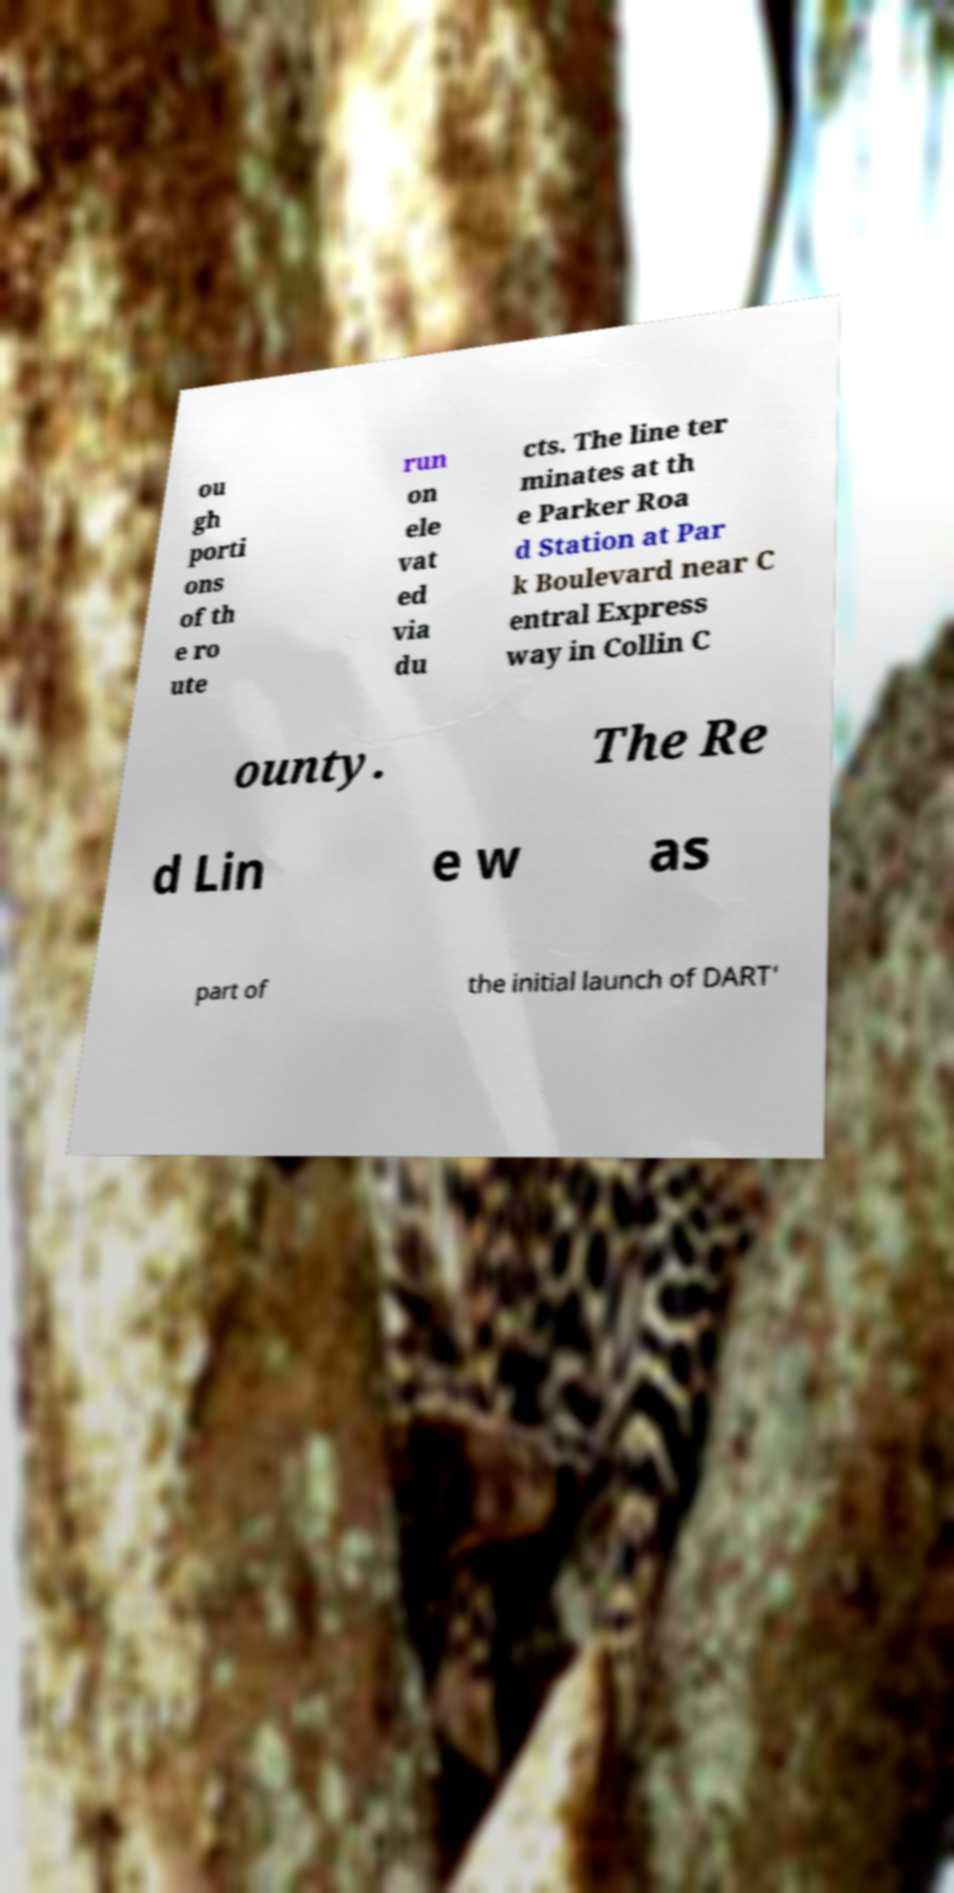What messages or text are displayed in this image? I need them in a readable, typed format. ou gh porti ons of th e ro ute run on ele vat ed via du cts. The line ter minates at th e Parker Roa d Station at Par k Boulevard near C entral Express way in Collin C ounty. The Re d Lin e w as part of the initial launch of DART' 